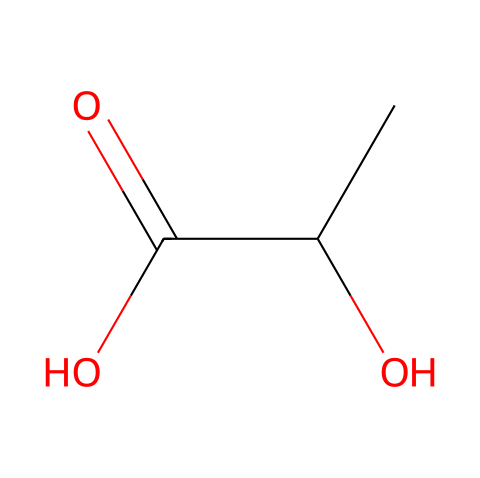how many carbon atoms are in lactic acid? The SMILES representation shows "CC", which indicates there are two carbon atoms and "C(=O)" suggests another carbon atom, making a total of three carbon atoms.
Answer: three what functional groups are present in lactic acid? The structure contains a hydroxyl group (-OH) and a carboxyl group (-COOH) as indicated by the "O" in "CC(O)" and the "C(=O)O".
Answer: hydroxyl and carboxyl groups what type of isomerism is exhibited by lactic acid? Lactic acid exhibits stereoisomerism because it has a chiral center represented by the carbon atom with an -OH group. This allows for D- and L- isomers.
Answer: stereoisomerism how many hydrogen atoms are there in lactic acid? Each carbon in the structure has a different number of hydrogen atoms to satisfy tetravalency. Counting them yields three hydrogen atoms associated with the first carbon and one for the second carbon plus another one from the hydroxyl group, totaling six.
Answer: six what type of reaction primarily produces lactic acid in muscles? During intense exercise, the body predominantly produces lactic acid through anaerobic glycolysis, where glucose is converted into lactic acid due to the lack of oxygen.
Answer: anaerobic glycolysis what is the pH of lactic acid in solution? Lactic acid is a weak acid, and in a typical aqueous solution, it has a pH of around 3.5, which indicates its acidity.
Answer: around 3.5 